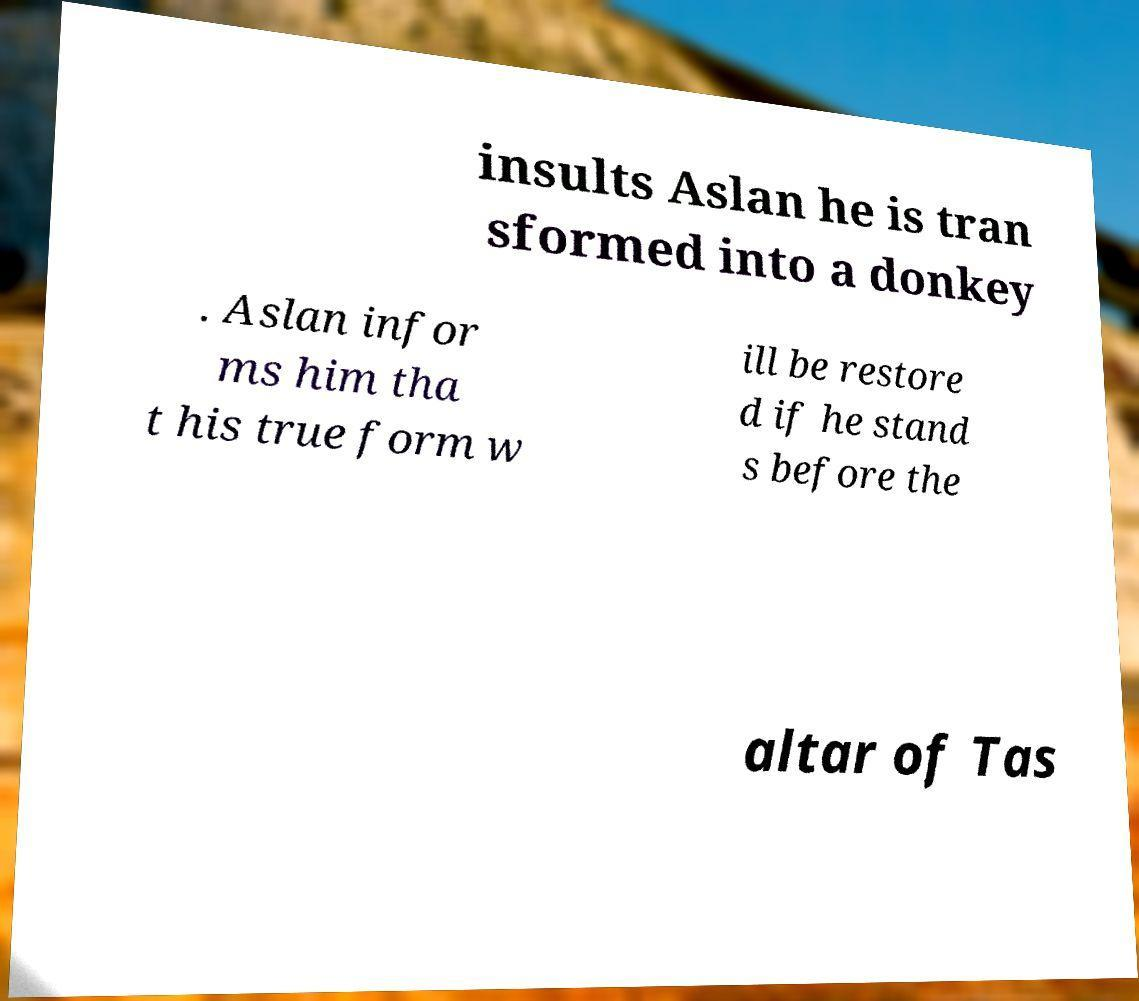There's text embedded in this image that I need extracted. Can you transcribe it verbatim? insults Aslan he is tran sformed into a donkey . Aslan infor ms him tha t his true form w ill be restore d if he stand s before the altar of Tas 